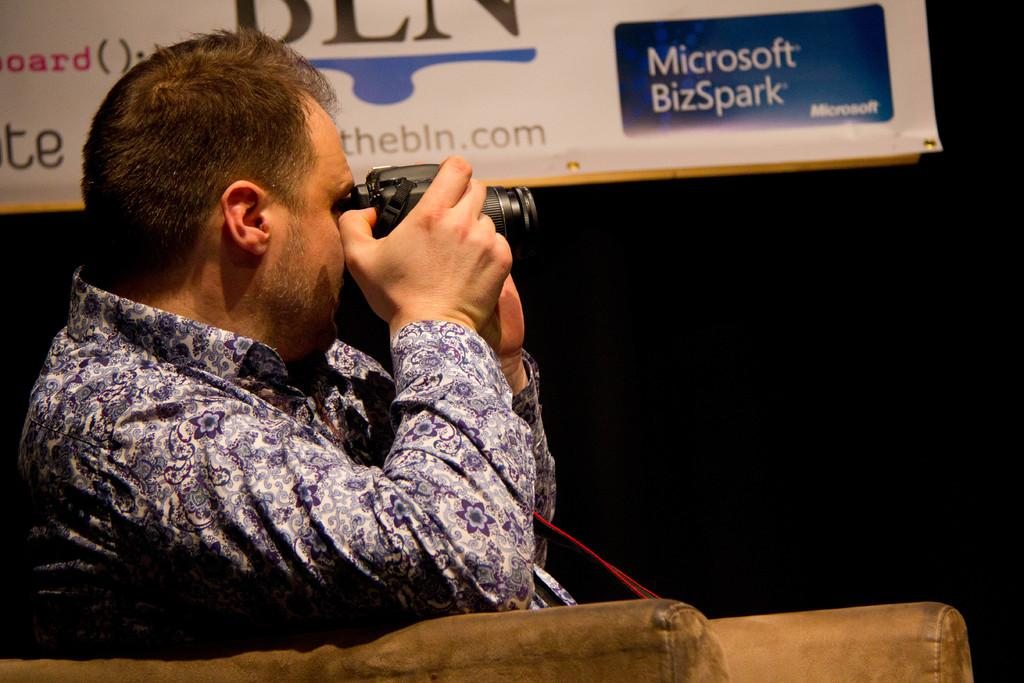Who is the main subject in the image? There is a person in the image. What is the person doing in the image? The person is sitting on a sofa and clicking an image with the camera. What is the person holding in the image? The person is holding a camera in the image. What type of group is represented in the image? There is no group represented in the image; it only features a single person. What type of harmony is depicted in the image? There is no harmony depicted in the image; it only shows a person sitting on a sofa and clicking an image with a camera. 